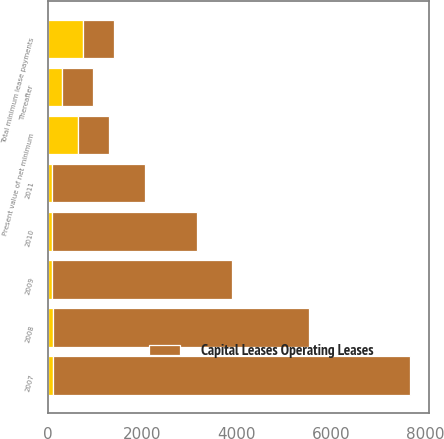<chart> <loc_0><loc_0><loc_500><loc_500><stacked_bar_chart><ecel><fcel>2007<fcel>2008<fcel>2009<fcel>2010<fcel>2011<fcel>Thereafter<fcel>Total minimum lease payments<fcel>Present value of net minimum<nl><fcel>nan<fcel>97<fcel>94<fcel>91<fcel>88<fcel>85<fcel>292<fcel>747<fcel>641<nl><fcel>Capital Leases Operating Leases<fcel>7586<fcel>5431<fcel>3799<fcel>3066<fcel>1972<fcel>657<fcel>649<fcel>649<nl></chart> 